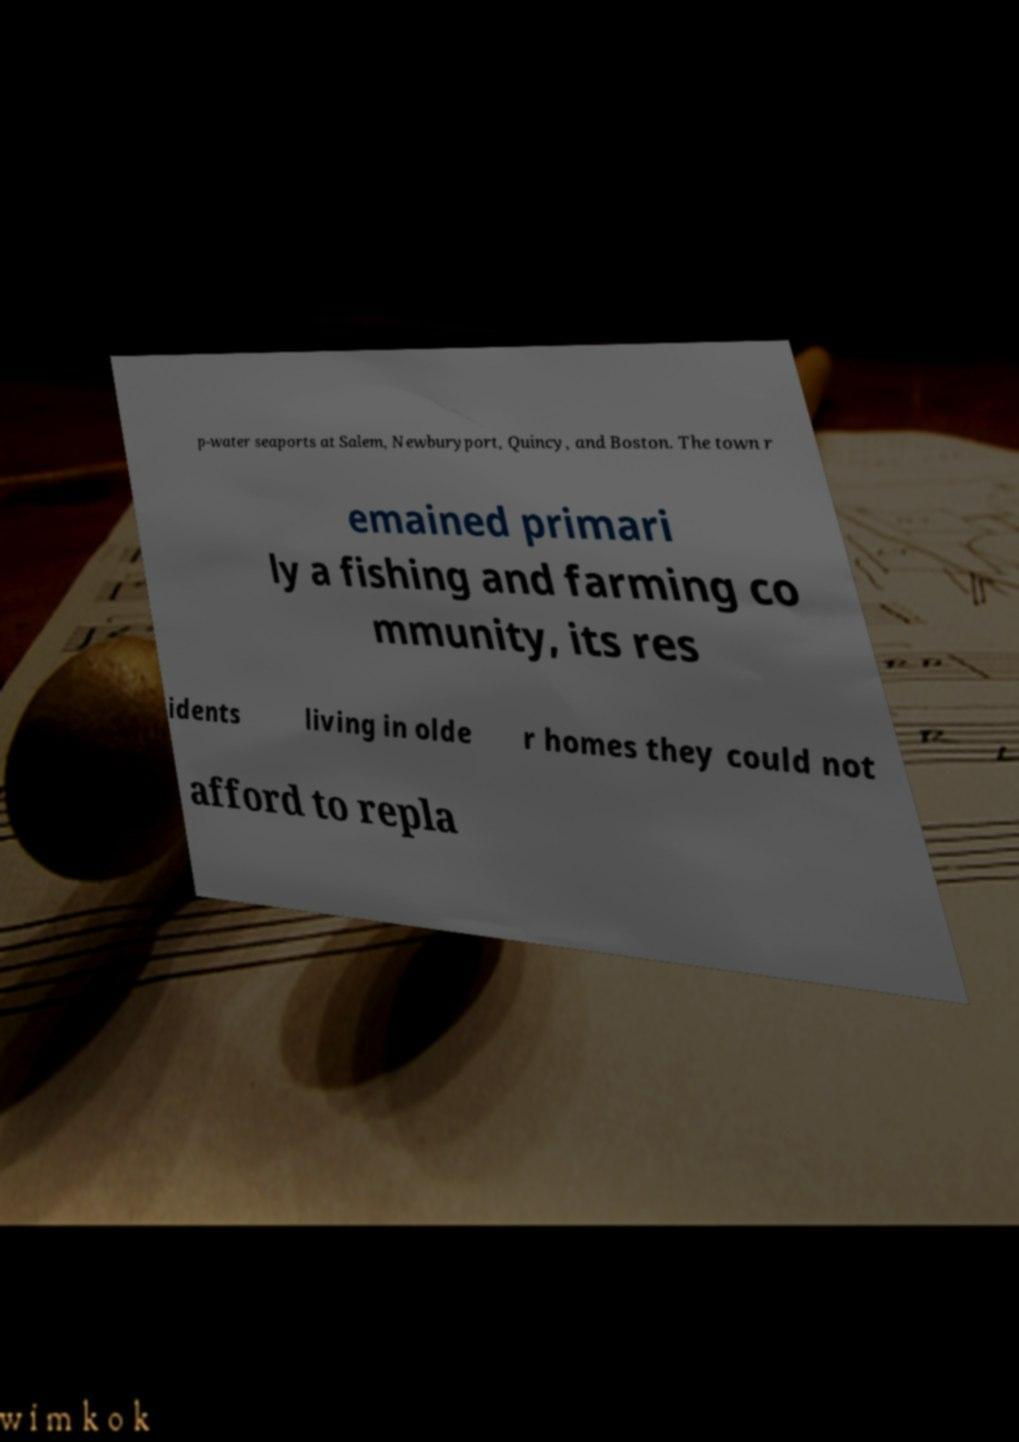I need the written content from this picture converted into text. Can you do that? p-water seaports at Salem, Newburyport, Quincy, and Boston. The town r emained primari ly a fishing and farming co mmunity, its res idents living in olde r homes they could not afford to repla 